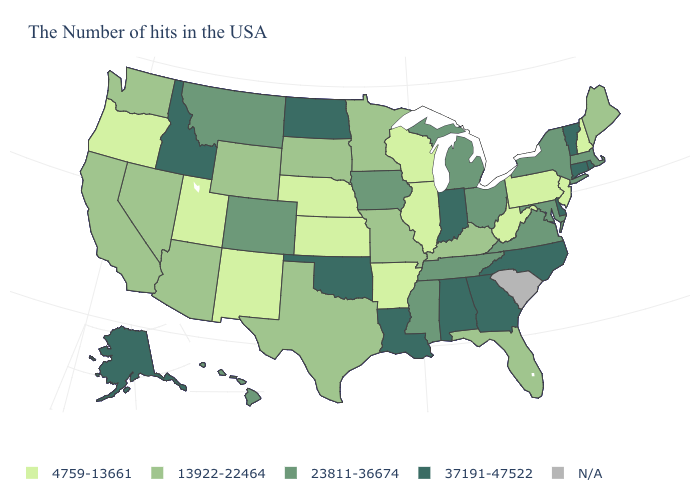Name the states that have a value in the range N/A?
Write a very short answer. South Carolina. How many symbols are there in the legend?
Answer briefly. 5. How many symbols are there in the legend?
Quick response, please. 5. What is the value of Missouri?
Keep it brief. 13922-22464. What is the value of New York?
Quick response, please. 23811-36674. What is the value of Ohio?
Answer briefly. 23811-36674. What is the value of Washington?
Give a very brief answer. 13922-22464. Name the states that have a value in the range 4759-13661?
Write a very short answer. New Hampshire, New Jersey, Pennsylvania, West Virginia, Wisconsin, Illinois, Arkansas, Kansas, Nebraska, New Mexico, Utah, Oregon. What is the value of Michigan?
Quick response, please. 23811-36674. What is the value of Nevada?
Short answer required. 13922-22464. Name the states that have a value in the range 13922-22464?
Answer briefly. Maine, Florida, Kentucky, Missouri, Minnesota, Texas, South Dakota, Wyoming, Arizona, Nevada, California, Washington. Among the states that border North Dakota , does Minnesota have the highest value?
Be succinct. No. Does Alabama have the highest value in the USA?
Be succinct. Yes. Does the first symbol in the legend represent the smallest category?
Short answer required. Yes. What is the highest value in states that border Oklahoma?
Concise answer only. 23811-36674. 